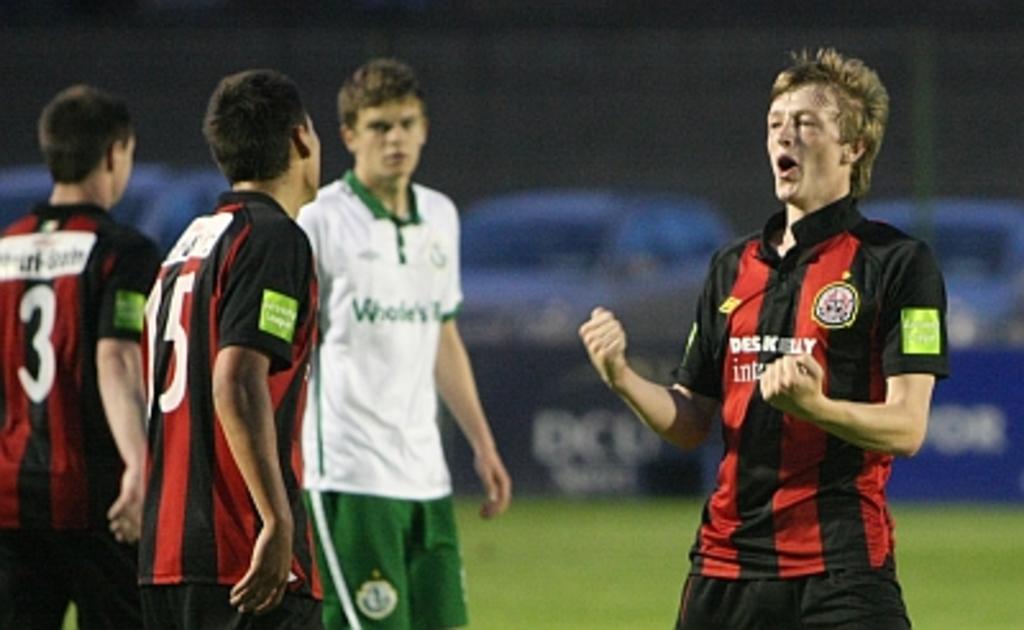Is there a player 3?
Ensure brevity in your answer.  Yes. 